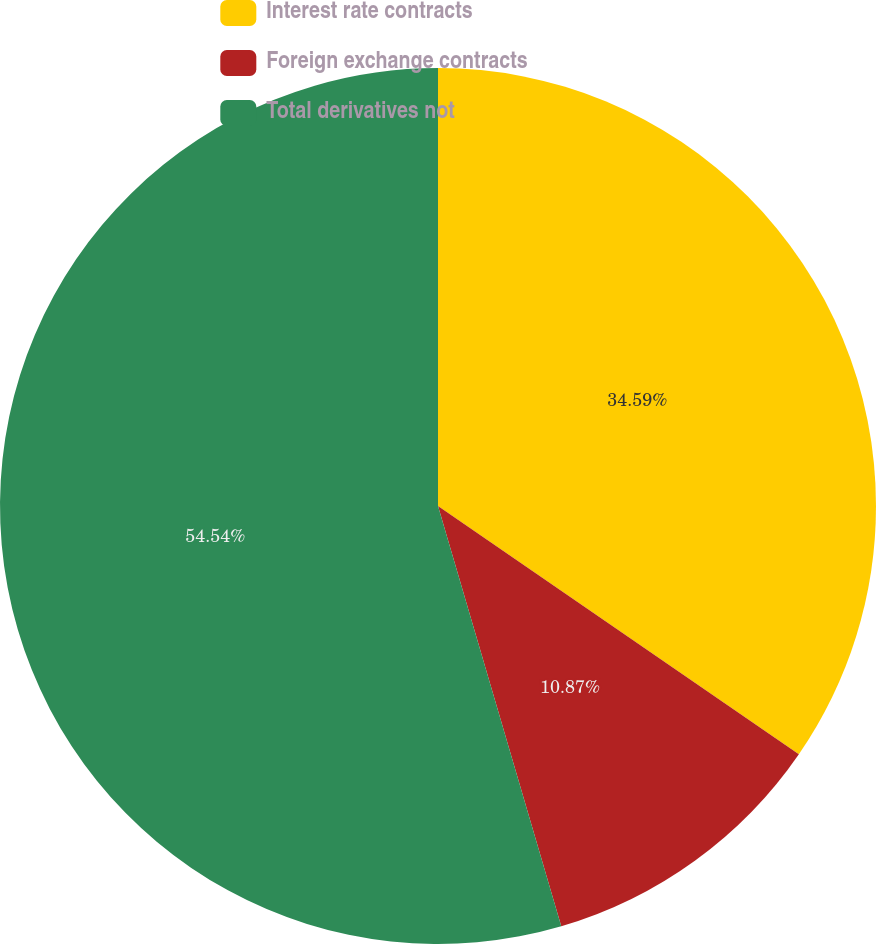Convert chart to OTSL. <chart><loc_0><loc_0><loc_500><loc_500><pie_chart><fcel>Interest rate contracts<fcel>Foreign exchange contracts<fcel>Total derivatives not<nl><fcel>34.59%<fcel>10.87%<fcel>54.54%<nl></chart> 